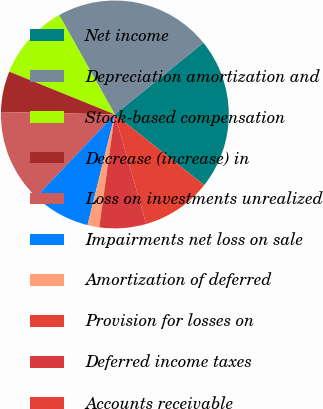<chart> <loc_0><loc_0><loc_500><loc_500><pie_chart><fcel>Net income<fcel>Depreciation amortization and<fcel>Stock-based compensation<fcel>Decrease (increase) in<fcel>Loss on investments unrealized<fcel>Impairments net loss on sale<fcel>Amortization of deferred<fcel>Provision for losses on<fcel>Deferred income taxes<fcel>Accounts receivable<nl><fcel>21.47%<fcel>22.3%<fcel>10.74%<fcel>5.79%<fcel>13.22%<fcel>8.27%<fcel>1.66%<fcel>0.01%<fcel>6.62%<fcel>9.92%<nl></chart> 